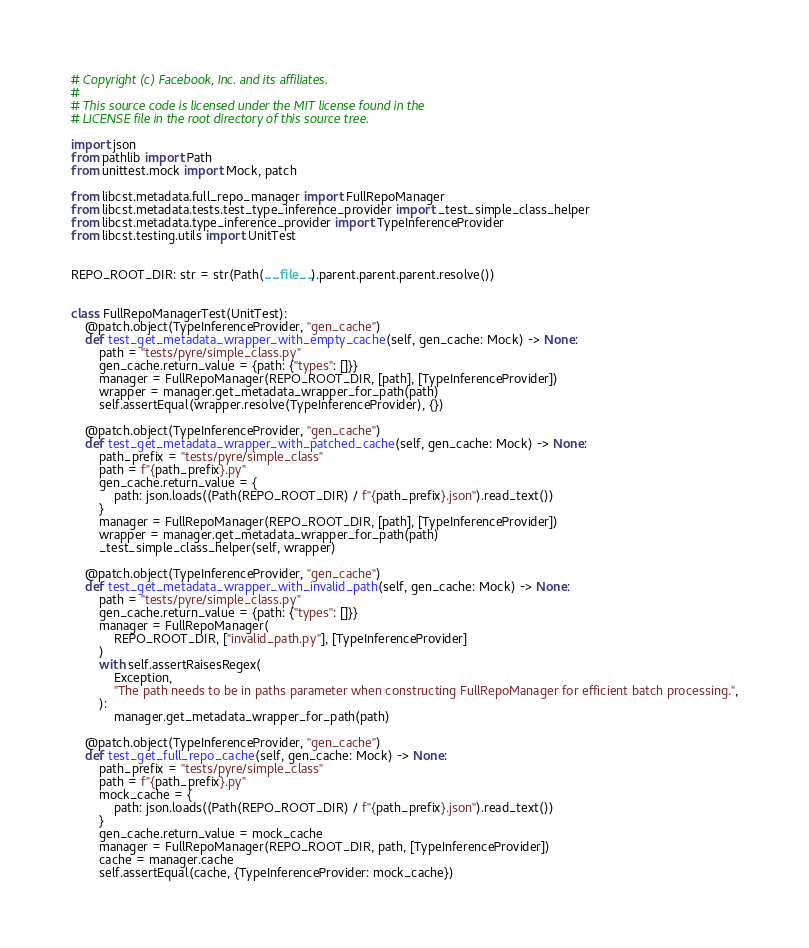<code> <loc_0><loc_0><loc_500><loc_500><_Python_># Copyright (c) Facebook, Inc. and its affiliates.
#
# This source code is licensed under the MIT license found in the
# LICENSE file in the root directory of this source tree.

import json
from pathlib import Path
from unittest.mock import Mock, patch

from libcst.metadata.full_repo_manager import FullRepoManager
from libcst.metadata.tests.test_type_inference_provider import _test_simple_class_helper
from libcst.metadata.type_inference_provider import TypeInferenceProvider
from libcst.testing.utils import UnitTest


REPO_ROOT_DIR: str = str(Path(__file__).parent.parent.parent.resolve())


class FullRepoManagerTest(UnitTest):
    @patch.object(TypeInferenceProvider, "gen_cache")
    def test_get_metadata_wrapper_with_empty_cache(self, gen_cache: Mock) -> None:
        path = "tests/pyre/simple_class.py"
        gen_cache.return_value = {path: {"types": []}}
        manager = FullRepoManager(REPO_ROOT_DIR, [path], [TypeInferenceProvider])
        wrapper = manager.get_metadata_wrapper_for_path(path)
        self.assertEqual(wrapper.resolve(TypeInferenceProvider), {})

    @patch.object(TypeInferenceProvider, "gen_cache")
    def test_get_metadata_wrapper_with_patched_cache(self, gen_cache: Mock) -> None:
        path_prefix = "tests/pyre/simple_class"
        path = f"{path_prefix}.py"
        gen_cache.return_value = {
            path: json.loads((Path(REPO_ROOT_DIR) / f"{path_prefix}.json").read_text())
        }
        manager = FullRepoManager(REPO_ROOT_DIR, [path], [TypeInferenceProvider])
        wrapper = manager.get_metadata_wrapper_for_path(path)
        _test_simple_class_helper(self, wrapper)

    @patch.object(TypeInferenceProvider, "gen_cache")
    def test_get_metadata_wrapper_with_invalid_path(self, gen_cache: Mock) -> None:
        path = "tests/pyre/simple_class.py"
        gen_cache.return_value = {path: {"types": []}}
        manager = FullRepoManager(
            REPO_ROOT_DIR, ["invalid_path.py"], [TypeInferenceProvider]
        )
        with self.assertRaisesRegex(
            Exception,
            "The path needs to be in paths parameter when constructing FullRepoManager for efficient batch processing.",
        ):
            manager.get_metadata_wrapper_for_path(path)

    @patch.object(TypeInferenceProvider, "gen_cache")
    def test_get_full_repo_cache(self, gen_cache: Mock) -> None:
        path_prefix = "tests/pyre/simple_class"
        path = f"{path_prefix}.py"
        mock_cache = {
            path: json.loads((Path(REPO_ROOT_DIR) / f"{path_prefix}.json").read_text())
        }
        gen_cache.return_value = mock_cache
        manager = FullRepoManager(REPO_ROOT_DIR, path, [TypeInferenceProvider])
        cache = manager.cache
        self.assertEqual(cache, {TypeInferenceProvider: mock_cache})
</code> 